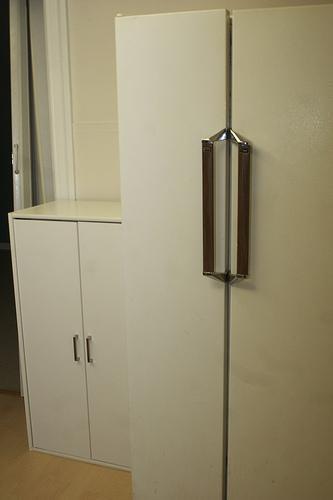How many fridges are pictured?
Give a very brief answer. 1. How many doors does the cupboard have?
Give a very brief answer. 2. 